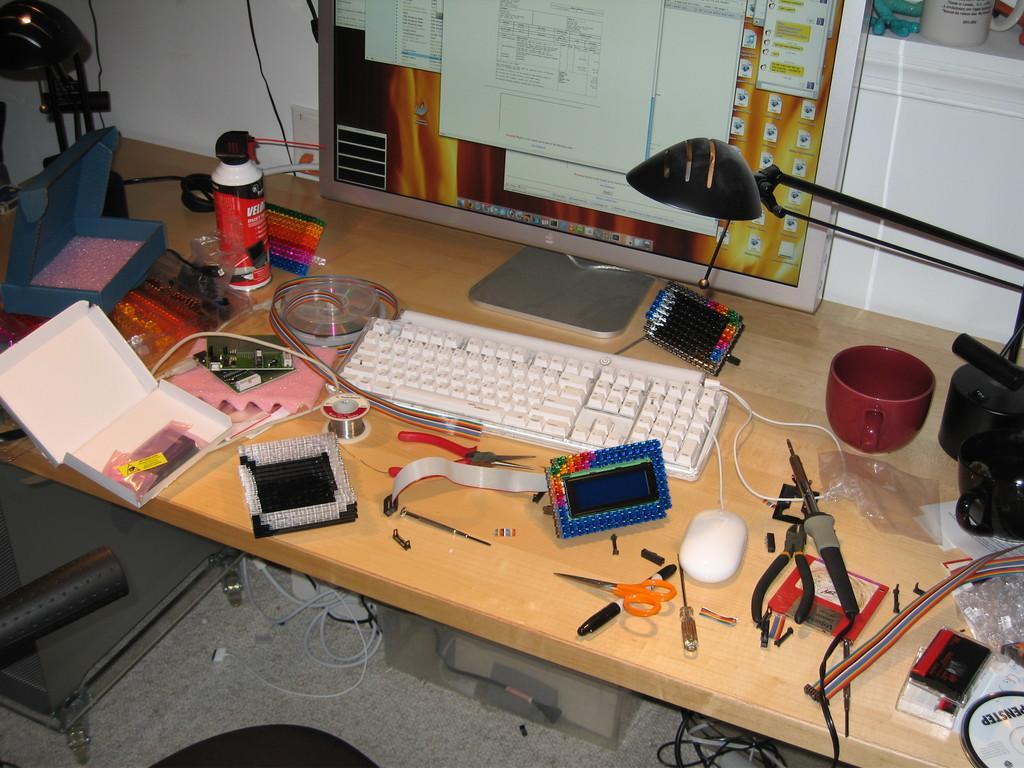In one or two sentences, can you explain what this image depicts? In this image we can see the table, on that there is a monitor, keyboard, mouse, wirecutter, soldering machine, scissor, boxes, bottle, cup, light, also we can see some other objects, under the table there are wires, also we can see the wall. 